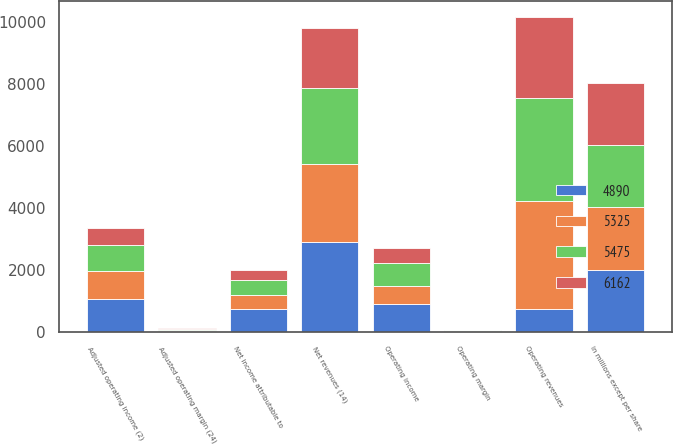Convert chart to OTSL. <chart><loc_0><loc_0><loc_500><loc_500><stacked_bar_chart><ecel><fcel>in millions except per share<fcel>Operating revenues<fcel>Net revenues (14)<fcel>Operating income<fcel>Adjusted operating income (2)<fcel>Operating margin<fcel>Adjusted operating margin (24)<fcel>Net income attributable to<nl><fcel>4890<fcel>2011<fcel>747.8<fcel>2898.4<fcel>898.1<fcel>1068.9<fcel>21.9<fcel>36.9<fcel>729.7<nl><fcel>5325<fcel>2010<fcel>3487.7<fcel>2521.1<fcel>589.9<fcel>897.7<fcel>16.9<fcel>35.6<fcel>465.7<nl><fcel>6162<fcel>2009<fcel>2627.3<fcel>1941<fcel>484.3<fcel>565.6<fcel>18.4<fcel>29.1<fcel>322.5<nl><fcel>5475<fcel>2008<fcel>3307.6<fcel>2437.9<fcel>747.8<fcel>826.1<fcel>22.6<fcel>33.9<fcel>481.7<nl></chart> 